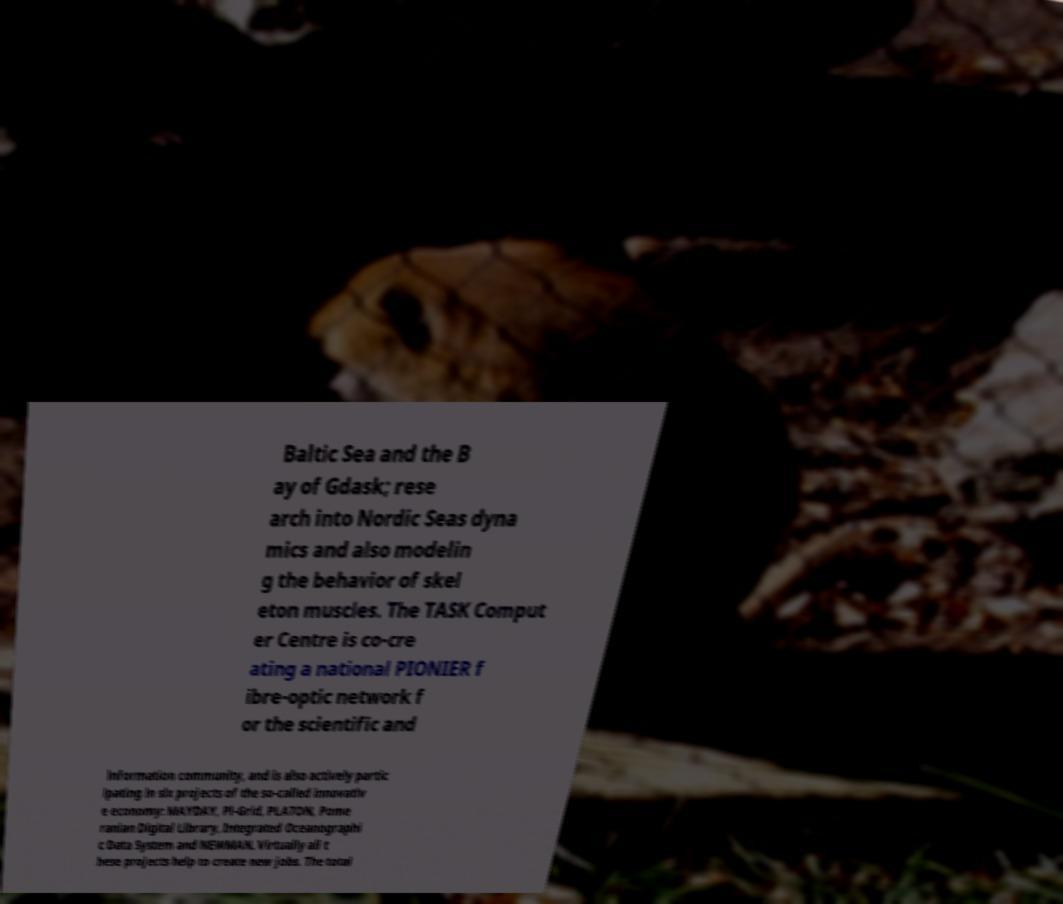Please identify and transcribe the text found in this image. Baltic Sea and the B ay of Gdask; rese arch into Nordic Seas dyna mics and also modelin g the behavior of skel eton muscles. The TASK Comput er Centre is co-cre ating a national PIONIER f ibre-optic network f or the scientific and information community, and is also actively partic ipating in six projects of the so-called innovativ e economy: MAYDAY, Pl-Grid, PLATON, Pome ranian Digital Library, Integrated Oceanographi c Data System and NEWMAN. Virtually all t hese projects help to create new jobs. The total 